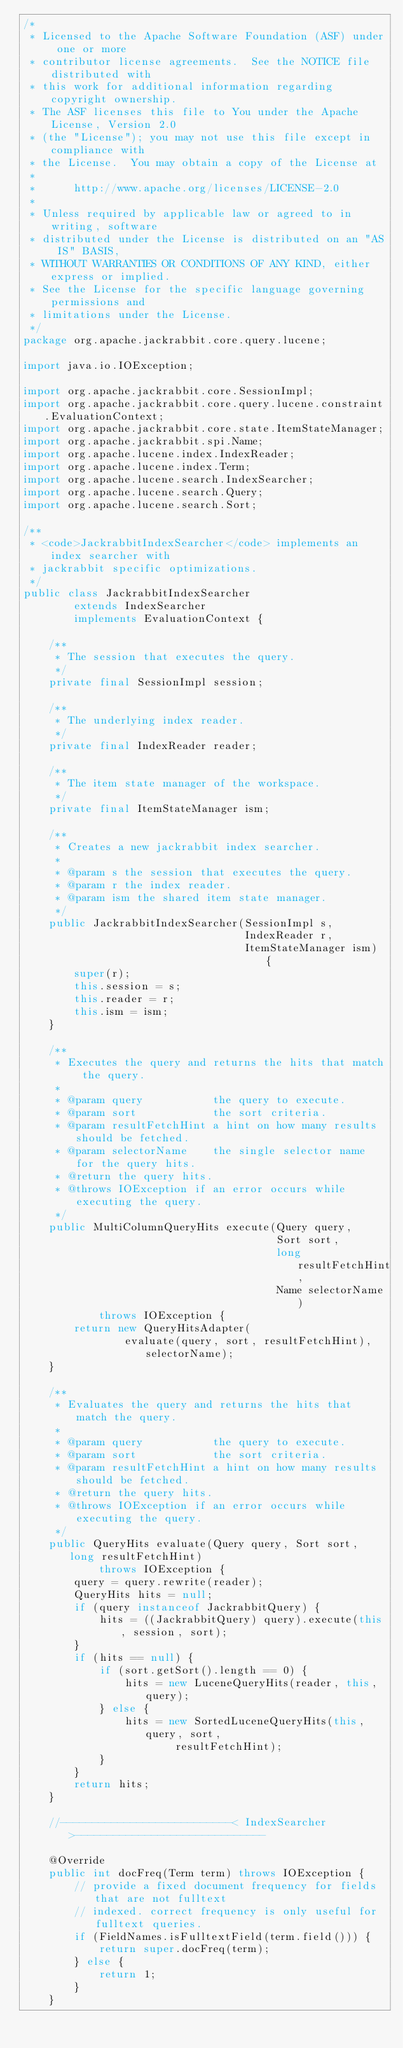Convert code to text. <code><loc_0><loc_0><loc_500><loc_500><_Java_>/*
 * Licensed to the Apache Software Foundation (ASF) under one or more
 * contributor license agreements.  See the NOTICE file distributed with
 * this work for additional information regarding copyright ownership.
 * The ASF licenses this file to You under the Apache License, Version 2.0
 * (the "License"); you may not use this file except in compliance with
 * the License.  You may obtain a copy of the License at
 *
 *      http://www.apache.org/licenses/LICENSE-2.0
 *
 * Unless required by applicable law or agreed to in writing, software
 * distributed under the License is distributed on an "AS IS" BASIS,
 * WITHOUT WARRANTIES OR CONDITIONS OF ANY KIND, either express or implied.
 * See the License for the specific language governing permissions and
 * limitations under the License.
 */
package org.apache.jackrabbit.core.query.lucene;

import java.io.IOException;

import org.apache.jackrabbit.core.SessionImpl;
import org.apache.jackrabbit.core.query.lucene.constraint.EvaluationContext;
import org.apache.jackrabbit.core.state.ItemStateManager;
import org.apache.jackrabbit.spi.Name;
import org.apache.lucene.index.IndexReader;
import org.apache.lucene.index.Term;
import org.apache.lucene.search.IndexSearcher;
import org.apache.lucene.search.Query;
import org.apache.lucene.search.Sort;

/**
 * <code>JackrabbitIndexSearcher</code> implements an index searcher with
 * jackrabbit specific optimizations.
 */
public class JackrabbitIndexSearcher
        extends IndexSearcher
        implements EvaluationContext {

    /**
     * The session that executes the query.
     */
    private final SessionImpl session;

    /**
     * The underlying index reader.
     */
    private final IndexReader reader;

    /**
     * The item state manager of the workspace.
     */
    private final ItemStateManager ism;

    /**
     * Creates a new jackrabbit index searcher.
     *
     * @param s the session that executes the query.
     * @param r the index reader.
     * @param ism the shared item state manager.
     */
    public JackrabbitIndexSearcher(SessionImpl s,
                                   IndexReader r,
                                   ItemStateManager ism) {
        super(r);
        this.session = s;
        this.reader = r;
        this.ism = ism;
    }

    /**
     * Executes the query and returns the hits that match the query.
     *
     * @param query           the query to execute.
     * @param sort            the sort criteria.
     * @param resultFetchHint a hint on how many results should be fetched.
     * @param selectorName    the single selector name for the query hits.
     * @return the query hits.
     * @throws IOException if an error occurs while executing the query.
     */
    public MultiColumnQueryHits execute(Query query,
                                        Sort sort,
                                        long resultFetchHint,
                                        Name selectorName)
            throws IOException {
        return new QueryHitsAdapter(
                evaluate(query, sort, resultFetchHint), selectorName);
    }

    /**
     * Evaluates the query and returns the hits that match the query.
     *
     * @param query           the query to execute.
     * @param sort            the sort criteria.
     * @param resultFetchHint a hint on how many results should be fetched.
     * @return the query hits.
     * @throws IOException if an error occurs while executing the query.
     */
    public QueryHits evaluate(Query query, Sort sort, long resultFetchHint)
            throws IOException {
        query = query.rewrite(reader);
        QueryHits hits = null;
        if (query instanceof JackrabbitQuery) {
            hits = ((JackrabbitQuery) query).execute(this, session, sort);
        }
        if (hits == null) {
            if (sort.getSort().length == 0) {
                hits = new LuceneQueryHits(reader, this, query);
            } else {
                hits = new SortedLuceneQueryHits(this, query, sort,
                        resultFetchHint);
            }
        }
        return hits;
    }

    //---------------------------< IndexSearcher >------------------------------

    @Override
    public int docFreq(Term term) throws IOException {
        // provide a fixed document frequency for fields that are not fulltext
        // indexed. correct frequency is only useful for fulltext queries.
        if (FieldNames.isFulltextField(term.field())) {
            return super.docFreq(term);
        } else {
            return 1;
        }
    }
</code> 